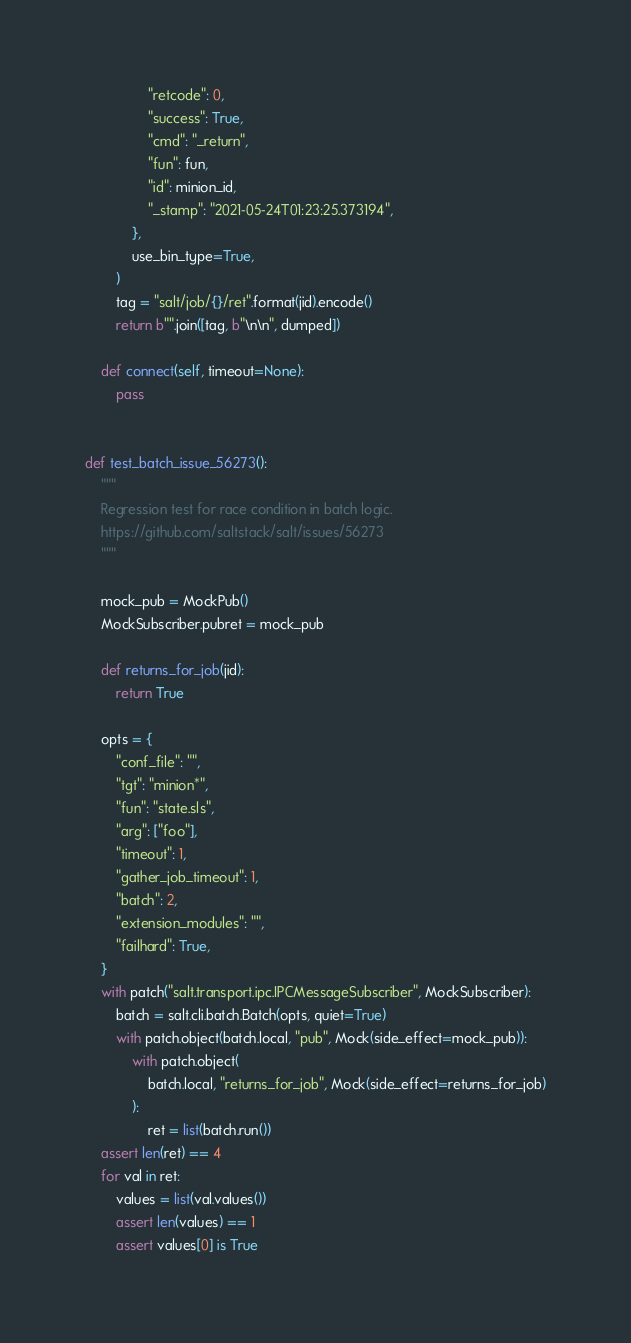Convert code to text. <code><loc_0><loc_0><loc_500><loc_500><_Python_>                "retcode": 0,
                "success": True,
                "cmd": "_return",
                "fun": fun,
                "id": minion_id,
                "_stamp": "2021-05-24T01:23:25.373194",
            },
            use_bin_type=True,
        )
        tag = "salt/job/{}/ret".format(jid).encode()
        return b"".join([tag, b"\n\n", dumped])

    def connect(self, timeout=None):
        pass


def test_batch_issue_56273():
    """
    Regression test for race condition in batch logic.
    https://github.com/saltstack/salt/issues/56273
    """

    mock_pub = MockPub()
    MockSubscriber.pubret = mock_pub

    def returns_for_job(jid):
        return True

    opts = {
        "conf_file": "",
        "tgt": "minion*",
        "fun": "state.sls",
        "arg": ["foo"],
        "timeout": 1,
        "gather_job_timeout": 1,
        "batch": 2,
        "extension_modules": "",
        "failhard": True,
    }
    with patch("salt.transport.ipc.IPCMessageSubscriber", MockSubscriber):
        batch = salt.cli.batch.Batch(opts, quiet=True)
        with patch.object(batch.local, "pub", Mock(side_effect=mock_pub)):
            with patch.object(
                batch.local, "returns_for_job", Mock(side_effect=returns_for_job)
            ):
                ret = list(batch.run())
    assert len(ret) == 4
    for val in ret:
        values = list(val.values())
        assert len(values) == 1
        assert values[0] is True
</code> 